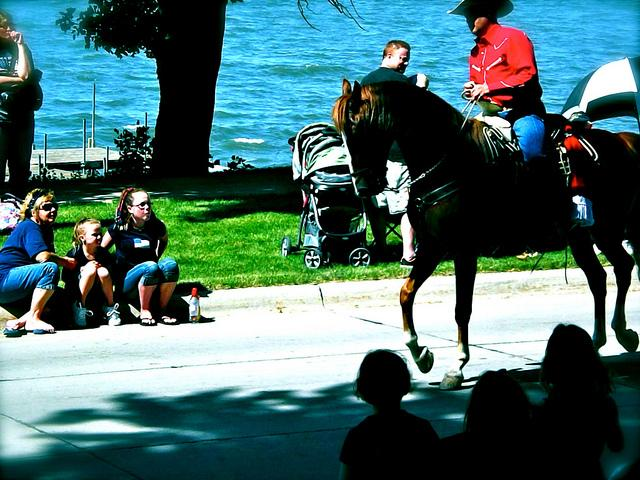The Horse and rider here are part of what? Please explain your reasoning. parade. There are people with small flags lining the street. The rider is also dressed for show. 